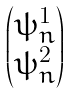Convert formula to latex. <formula><loc_0><loc_0><loc_500><loc_500>\begin{pmatrix} \psi ^ { 1 } _ { n } \\ \psi ^ { 2 } _ { n } \end{pmatrix}</formula> 